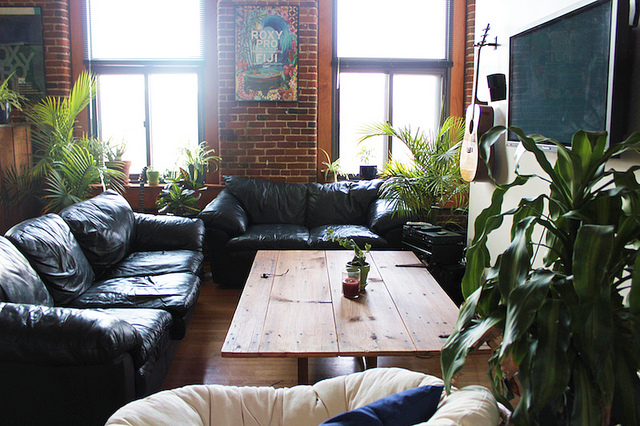Identify the text contained in this image. ROXY PRO FIJI 